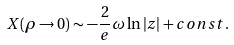<formula> <loc_0><loc_0><loc_500><loc_500>X ( \rho \rightarrow 0 ) \sim - \frac { 2 } { e } \omega \ln \left | z \right | + c o n s t .</formula> 